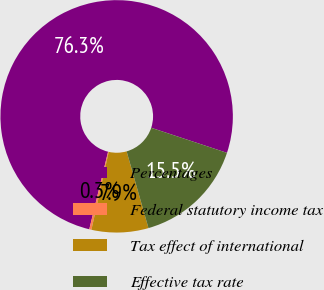Convert chart to OTSL. <chart><loc_0><loc_0><loc_500><loc_500><pie_chart><fcel>Percentages<fcel>Federal statutory income tax<fcel>Tax effect of international<fcel>Effective tax rate<nl><fcel>76.31%<fcel>0.3%<fcel>7.9%<fcel>15.5%<nl></chart> 